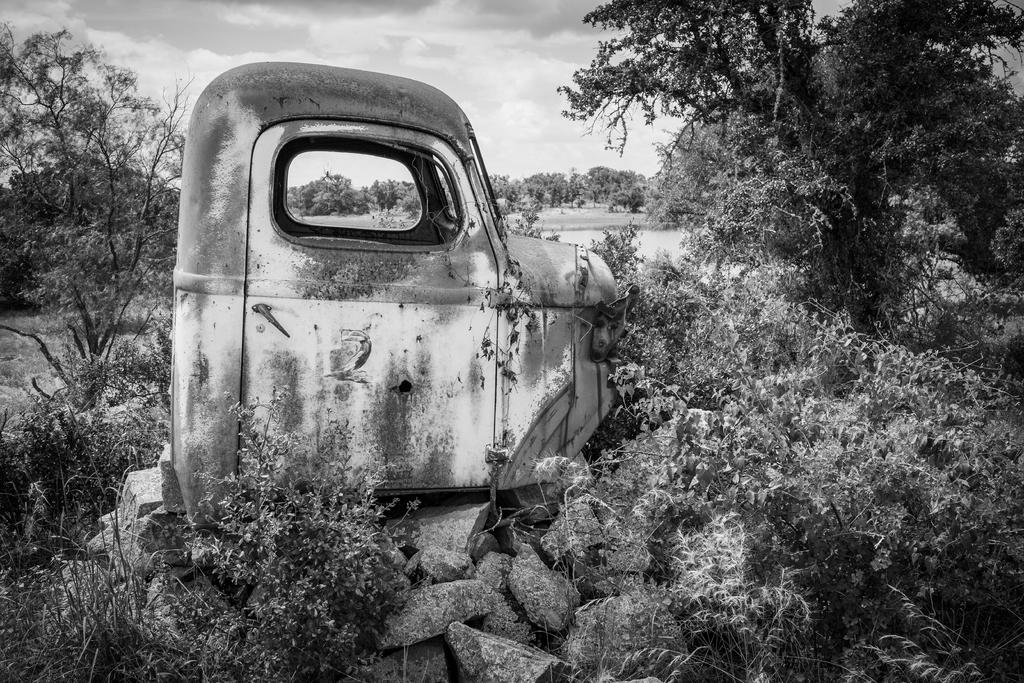What is the color scheme of the image? The image is black and white. What vehicle is present in the image? There is a truck in the image. Which part of the truck is visible? The truck's front part is visible. What type of vegetation is present on either side of the truck? There are trees on either side of the truck. What is present at the bottom of the image? There are stones at the bottom of the image. Can you tell me how many horses are pulling the truck in the image? There are no horses present in the image; it features a truck. 